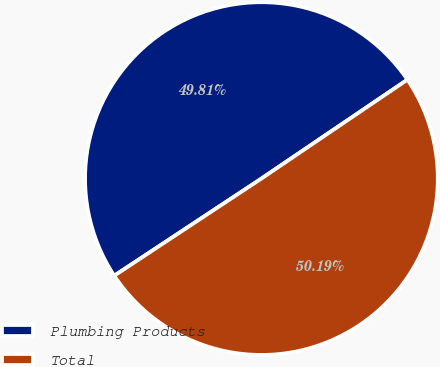Convert chart. <chart><loc_0><loc_0><loc_500><loc_500><pie_chart><fcel>Plumbing Products<fcel>Total<nl><fcel>49.81%<fcel>50.19%<nl></chart> 